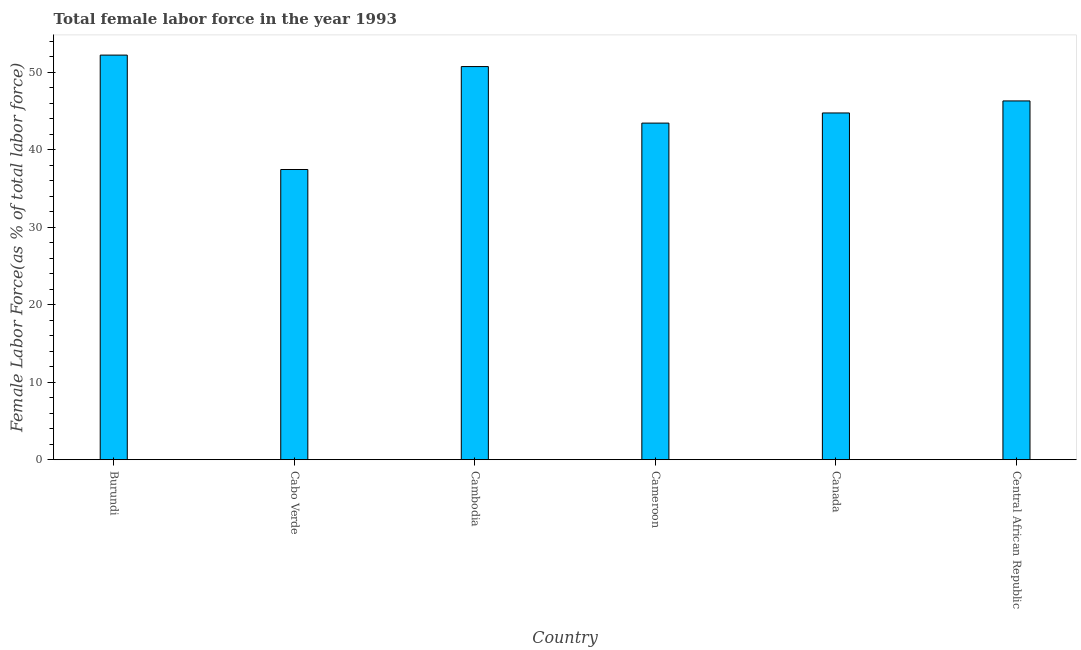Does the graph contain any zero values?
Your answer should be very brief. No. What is the title of the graph?
Offer a terse response. Total female labor force in the year 1993. What is the label or title of the X-axis?
Offer a very short reply. Country. What is the label or title of the Y-axis?
Your answer should be very brief. Female Labor Force(as % of total labor force). What is the total female labor force in Cabo Verde?
Provide a short and direct response. 37.44. Across all countries, what is the maximum total female labor force?
Ensure brevity in your answer.  52.2. Across all countries, what is the minimum total female labor force?
Provide a short and direct response. 37.44. In which country was the total female labor force maximum?
Keep it short and to the point. Burundi. In which country was the total female labor force minimum?
Your answer should be very brief. Cabo Verde. What is the sum of the total female labor force?
Offer a very short reply. 274.83. What is the difference between the total female labor force in Canada and Central African Republic?
Offer a terse response. -1.55. What is the average total female labor force per country?
Make the answer very short. 45.8. What is the median total female labor force?
Ensure brevity in your answer.  45.51. What is the ratio of the total female labor force in Burundi to that in Central African Republic?
Keep it short and to the point. 1.13. Is the difference between the total female labor force in Burundi and Central African Republic greater than the difference between any two countries?
Your answer should be very brief. No. What is the difference between the highest and the second highest total female labor force?
Give a very brief answer. 1.48. What is the difference between the highest and the lowest total female labor force?
Ensure brevity in your answer.  14.76. Are the values on the major ticks of Y-axis written in scientific E-notation?
Keep it short and to the point. No. What is the Female Labor Force(as % of total labor force) in Burundi?
Ensure brevity in your answer.  52.2. What is the Female Labor Force(as % of total labor force) of Cabo Verde?
Keep it short and to the point. 37.44. What is the Female Labor Force(as % of total labor force) of Cambodia?
Offer a terse response. 50.72. What is the Female Labor Force(as % of total labor force) of Cameroon?
Provide a succinct answer. 43.43. What is the Female Labor Force(as % of total labor force) in Canada?
Offer a very short reply. 44.74. What is the Female Labor Force(as % of total labor force) in Central African Republic?
Ensure brevity in your answer.  46.29. What is the difference between the Female Labor Force(as % of total labor force) in Burundi and Cabo Verde?
Make the answer very short. 14.76. What is the difference between the Female Labor Force(as % of total labor force) in Burundi and Cambodia?
Provide a short and direct response. 1.48. What is the difference between the Female Labor Force(as % of total labor force) in Burundi and Cameroon?
Provide a succinct answer. 8.77. What is the difference between the Female Labor Force(as % of total labor force) in Burundi and Canada?
Provide a succinct answer. 7.47. What is the difference between the Female Labor Force(as % of total labor force) in Burundi and Central African Republic?
Your answer should be very brief. 5.91. What is the difference between the Female Labor Force(as % of total labor force) in Cabo Verde and Cambodia?
Make the answer very short. -13.28. What is the difference between the Female Labor Force(as % of total labor force) in Cabo Verde and Cameroon?
Offer a terse response. -5.99. What is the difference between the Female Labor Force(as % of total labor force) in Cabo Verde and Canada?
Provide a short and direct response. -7.3. What is the difference between the Female Labor Force(as % of total labor force) in Cabo Verde and Central African Republic?
Ensure brevity in your answer.  -8.85. What is the difference between the Female Labor Force(as % of total labor force) in Cambodia and Cameroon?
Ensure brevity in your answer.  7.29. What is the difference between the Female Labor Force(as % of total labor force) in Cambodia and Canada?
Your answer should be very brief. 5.98. What is the difference between the Female Labor Force(as % of total labor force) in Cambodia and Central African Republic?
Offer a very short reply. 4.43. What is the difference between the Female Labor Force(as % of total labor force) in Cameroon and Canada?
Keep it short and to the point. -1.31. What is the difference between the Female Labor Force(as % of total labor force) in Cameroon and Central African Republic?
Your answer should be very brief. -2.86. What is the difference between the Female Labor Force(as % of total labor force) in Canada and Central African Republic?
Ensure brevity in your answer.  -1.55. What is the ratio of the Female Labor Force(as % of total labor force) in Burundi to that in Cabo Verde?
Offer a terse response. 1.39. What is the ratio of the Female Labor Force(as % of total labor force) in Burundi to that in Cambodia?
Ensure brevity in your answer.  1.03. What is the ratio of the Female Labor Force(as % of total labor force) in Burundi to that in Cameroon?
Your response must be concise. 1.2. What is the ratio of the Female Labor Force(as % of total labor force) in Burundi to that in Canada?
Provide a short and direct response. 1.17. What is the ratio of the Female Labor Force(as % of total labor force) in Burundi to that in Central African Republic?
Your answer should be very brief. 1.13. What is the ratio of the Female Labor Force(as % of total labor force) in Cabo Verde to that in Cambodia?
Offer a very short reply. 0.74. What is the ratio of the Female Labor Force(as % of total labor force) in Cabo Verde to that in Cameroon?
Offer a terse response. 0.86. What is the ratio of the Female Labor Force(as % of total labor force) in Cabo Verde to that in Canada?
Provide a succinct answer. 0.84. What is the ratio of the Female Labor Force(as % of total labor force) in Cabo Verde to that in Central African Republic?
Your response must be concise. 0.81. What is the ratio of the Female Labor Force(as % of total labor force) in Cambodia to that in Cameroon?
Provide a short and direct response. 1.17. What is the ratio of the Female Labor Force(as % of total labor force) in Cambodia to that in Canada?
Keep it short and to the point. 1.13. What is the ratio of the Female Labor Force(as % of total labor force) in Cambodia to that in Central African Republic?
Offer a terse response. 1.1. What is the ratio of the Female Labor Force(as % of total labor force) in Cameroon to that in Central African Republic?
Ensure brevity in your answer.  0.94. What is the ratio of the Female Labor Force(as % of total labor force) in Canada to that in Central African Republic?
Your response must be concise. 0.97. 